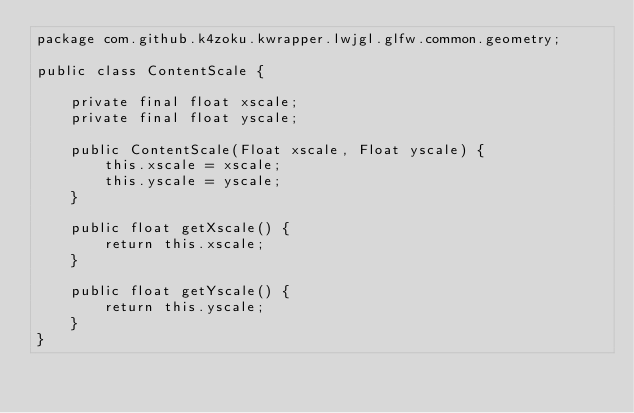Convert code to text. <code><loc_0><loc_0><loc_500><loc_500><_Java_>package com.github.k4zoku.kwrapper.lwjgl.glfw.common.geometry;

public class ContentScale {

    private final float xscale;
    private final float yscale;

    public ContentScale(Float xscale, Float yscale) {
        this.xscale = xscale;
        this.yscale = yscale;
    }

    public float getXscale() {
        return this.xscale;
    }

    public float getYscale() {
        return this.yscale;
    }
}
</code> 